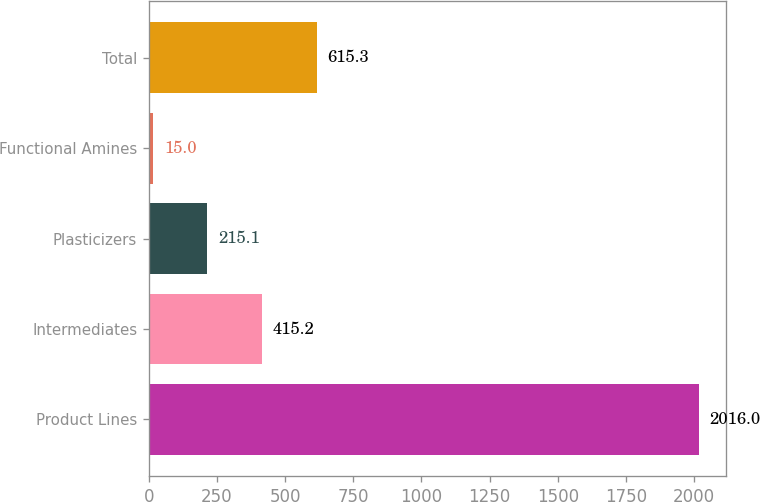<chart> <loc_0><loc_0><loc_500><loc_500><bar_chart><fcel>Product Lines<fcel>Intermediates<fcel>Plasticizers<fcel>Functional Amines<fcel>Total<nl><fcel>2016<fcel>415.2<fcel>215.1<fcel>15<fcel>615.3<nl></chart> 